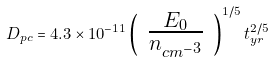<formula> <loc_0><loc_0><loc_500><loc_500>D _ { p c } = 4 . 3 \times 1 0 ^ { - 1 1 } \left ( \begin{array} { c } \frac { E _ { 0 } } { n _ { c m ^ { - 3 } } } \end{array} \right ) ^ { 1 / 5 } t _ { y r } ^ { 2 / 5 }</formula> 